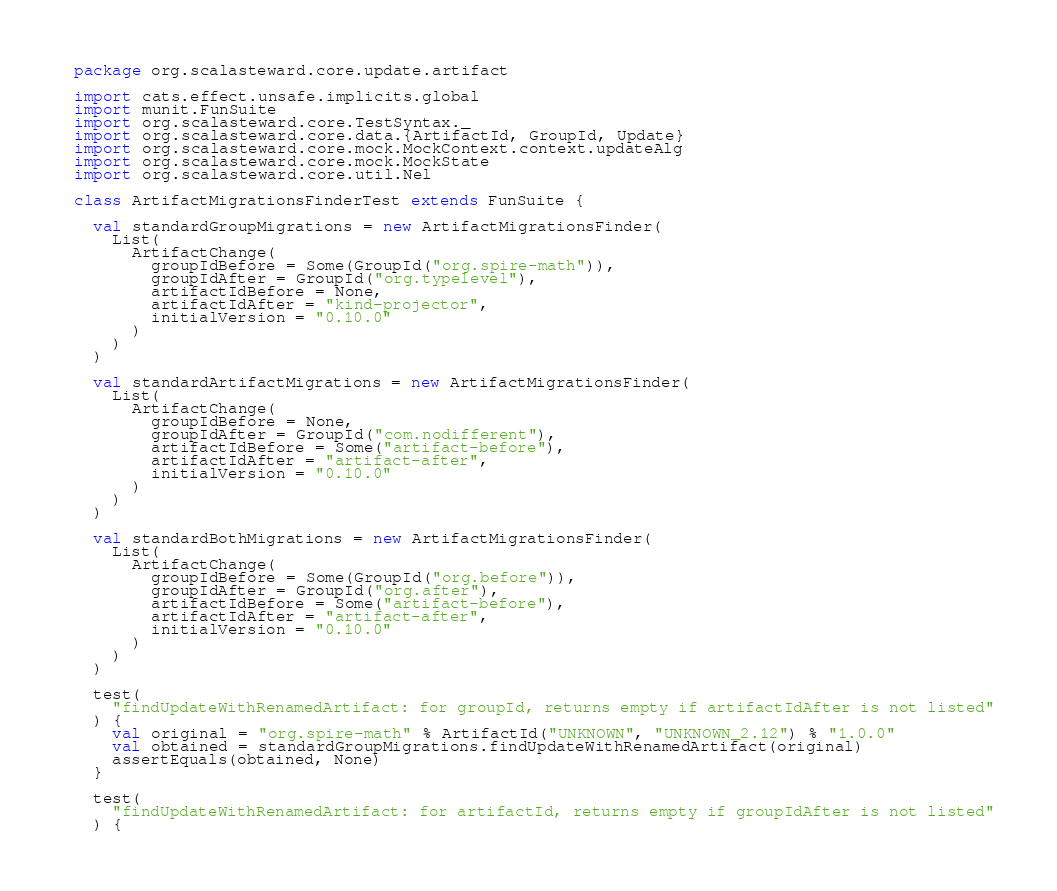Convert code to text. <code><loc_0><loc_0><loc_500><loc_500><_Scala_>package org.scalasteward.core.update.artifact

import cats.effect.unsafe.implicits.global
import munit.FunSuite
import org.scalasteward.core.TestSyntax._
import org.scalasteward.core.data.{ArtifactId, GroupId, Update}
import org.scalasteward.core.mock.MockContext.context.updateAlg
import org.scalasteward.core.mock.MockState
import org.scalasteward.core.util.Nel

class ArtifactMigrationsFinderTest extends FunSuite {

  val standardGroupMigrations = new ArtifactMigrationsFinder(
    List(
      ArtifactChange(
        groupIdBefore = Some(GroupId("org.spire-math")),
        groupIdAfter = GroupId("org.typelevel"),
        artifactIdBefore = None,
        artifactIdAfter = "kind-projector",
        initialVersion = "0.10.0"
      )
    )
  )

  val standardArtifactMigrations = new ArtifactMigrationsFinder(
    List(
      ArtifactChange(
        groupIdBefore = None,
        groupIdAfter = GroupId("com.nodifferent"),
        artifactIdBefore = Some("artifact-before"),
        artifactIdAfter = "artifact-after",
        initialVersion = "0.10.0"
      )
    )
  )

  val standardBothMigrations = new ArtifactMigrationsFinder(
    List(
      ArtifactChange(
        groupIdBefore = Some(GroupId("org.before")),
        groupIdAfter = GroupId("org.after"),
        artifactIdBefore = Some("artifact-before"),
        artifactIdAfter = "artifact-after",
        initialVersion = "0.10.0"
      )
    )
  )

  test(
    "findUpdateWithRenamedArtifact: for groupId, returns empty if artifactIdAfter is not listed"
  ) {
    val original = "org.spire-math" % ArtifactId("UNKNOWN", "UNKNOWN_2.12") % "1.0.0"
    val obtained = standardGroupMigrations.findUpdateWithRenamedArtifact(original)
    assertEquals(obtained, None)
  }

  test(
    "findUpdateWithRenamedArtifact: for artifactId, returns empty if groupIdAfter is not listed"
  ) {</code> 